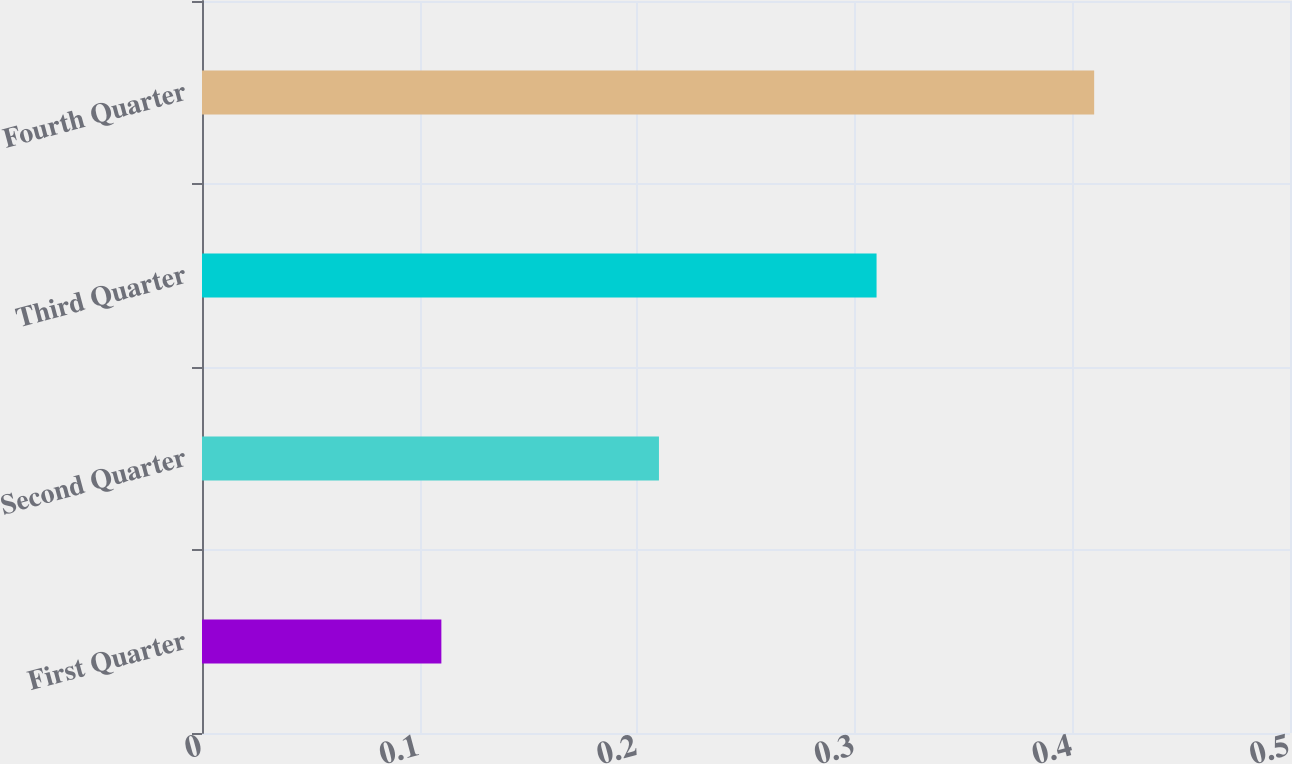Convert chart. <chart><loc_0><loc_0><loc_500><loc_500><bar_chart><fcel>First Quarter<fcel>Second Quarter<fcel>Third Quarter<fcel>Fourth Quarter<nl><fcel>0.11<fcel>0.21<fcel>0.31<fcel>0.41<nl></chart> 